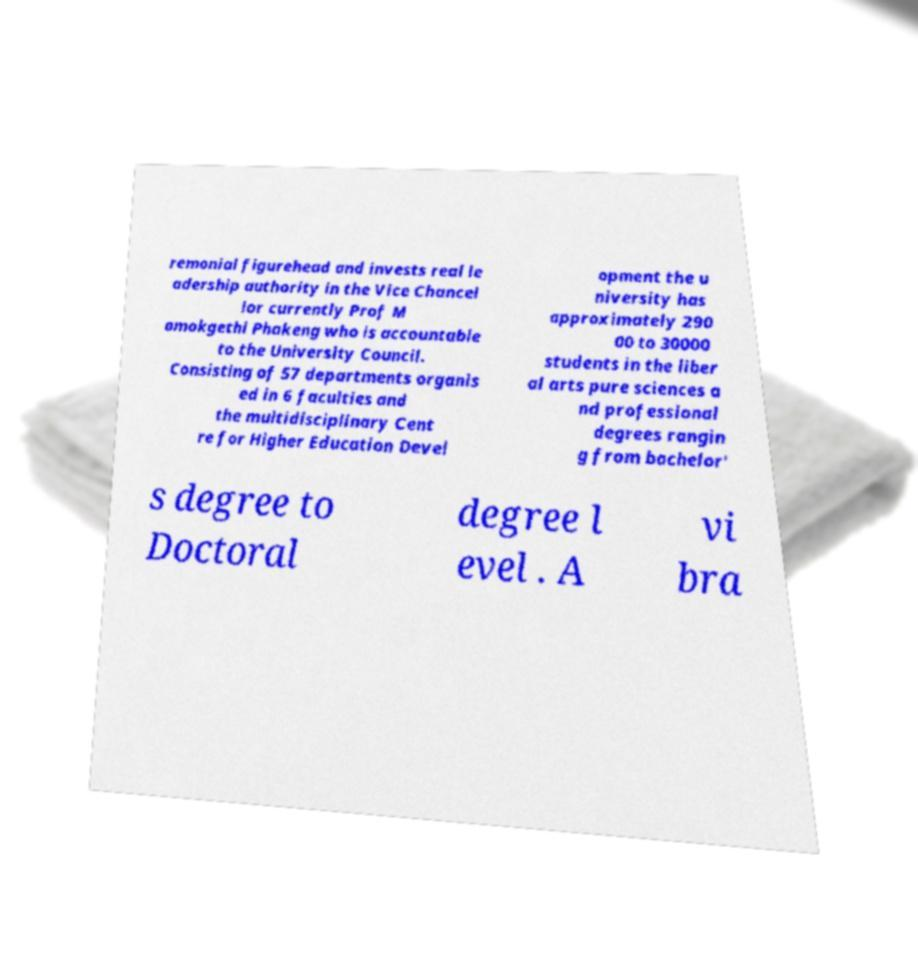What messages or text are displayed in this image? I need them in a readable, typed format. remonial figurehead and invests real le adership authority in the Vice Chancel lor currently Prof M amokgethi Phakeng who is accountable to the University Council. Consisting of 57 departments organis ed in 6 faculties and the multidisciplinary Cent re for Higher Education Devel opment the u niversity has approximately 290 00 to 30000 students in the liber al arts pure sciences a nd professional degrees rangin g from bachelor' s degree to Doctoral degree l evel . A vi bra 